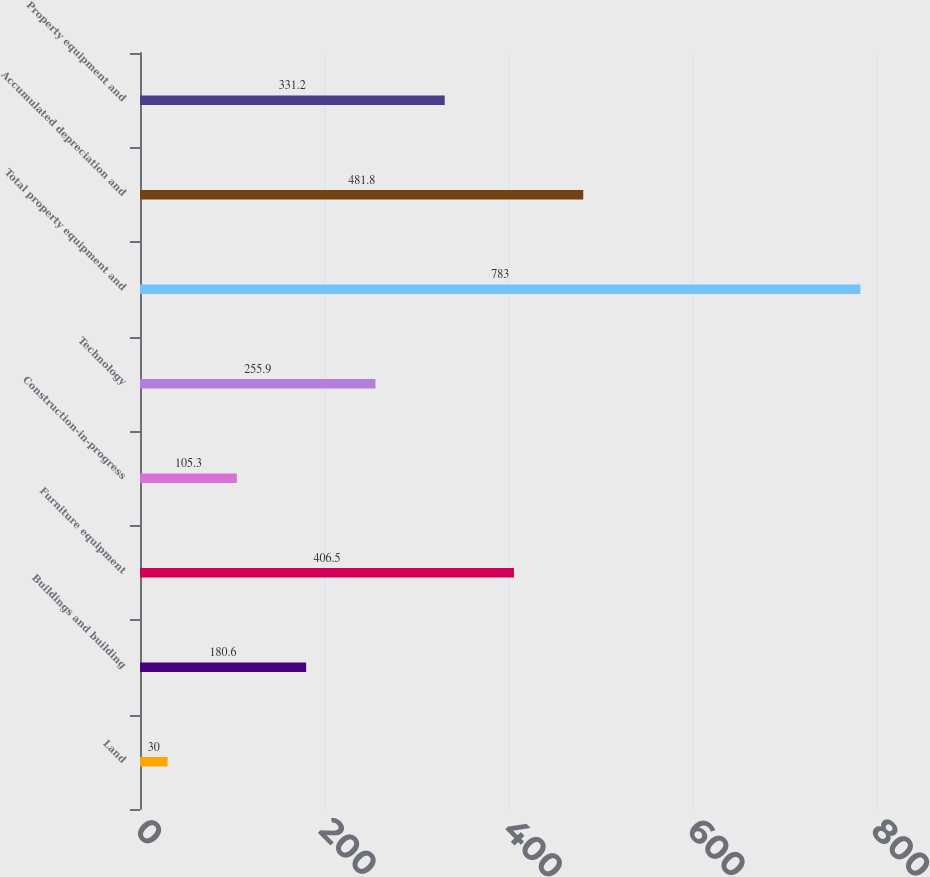Convert chart to OTSL. <chart><loc_0><loc_0><loc_500><loc_500><bar_chart><fcel>Land<fcel>Buildings and building<fcel>Furniture equipment<fcel>Construction-in-progress<fcel>Technology<fcel>Total property equipment and<fcel>Accumulated depreciation and<fcel>Property equipment and<nl><fcel>30<fcel>180.6<fcel>406.5<fcel>105.3<fcel>255.9<fcel>783<fcel>481.8<fcel>331.2<nl></chart> 